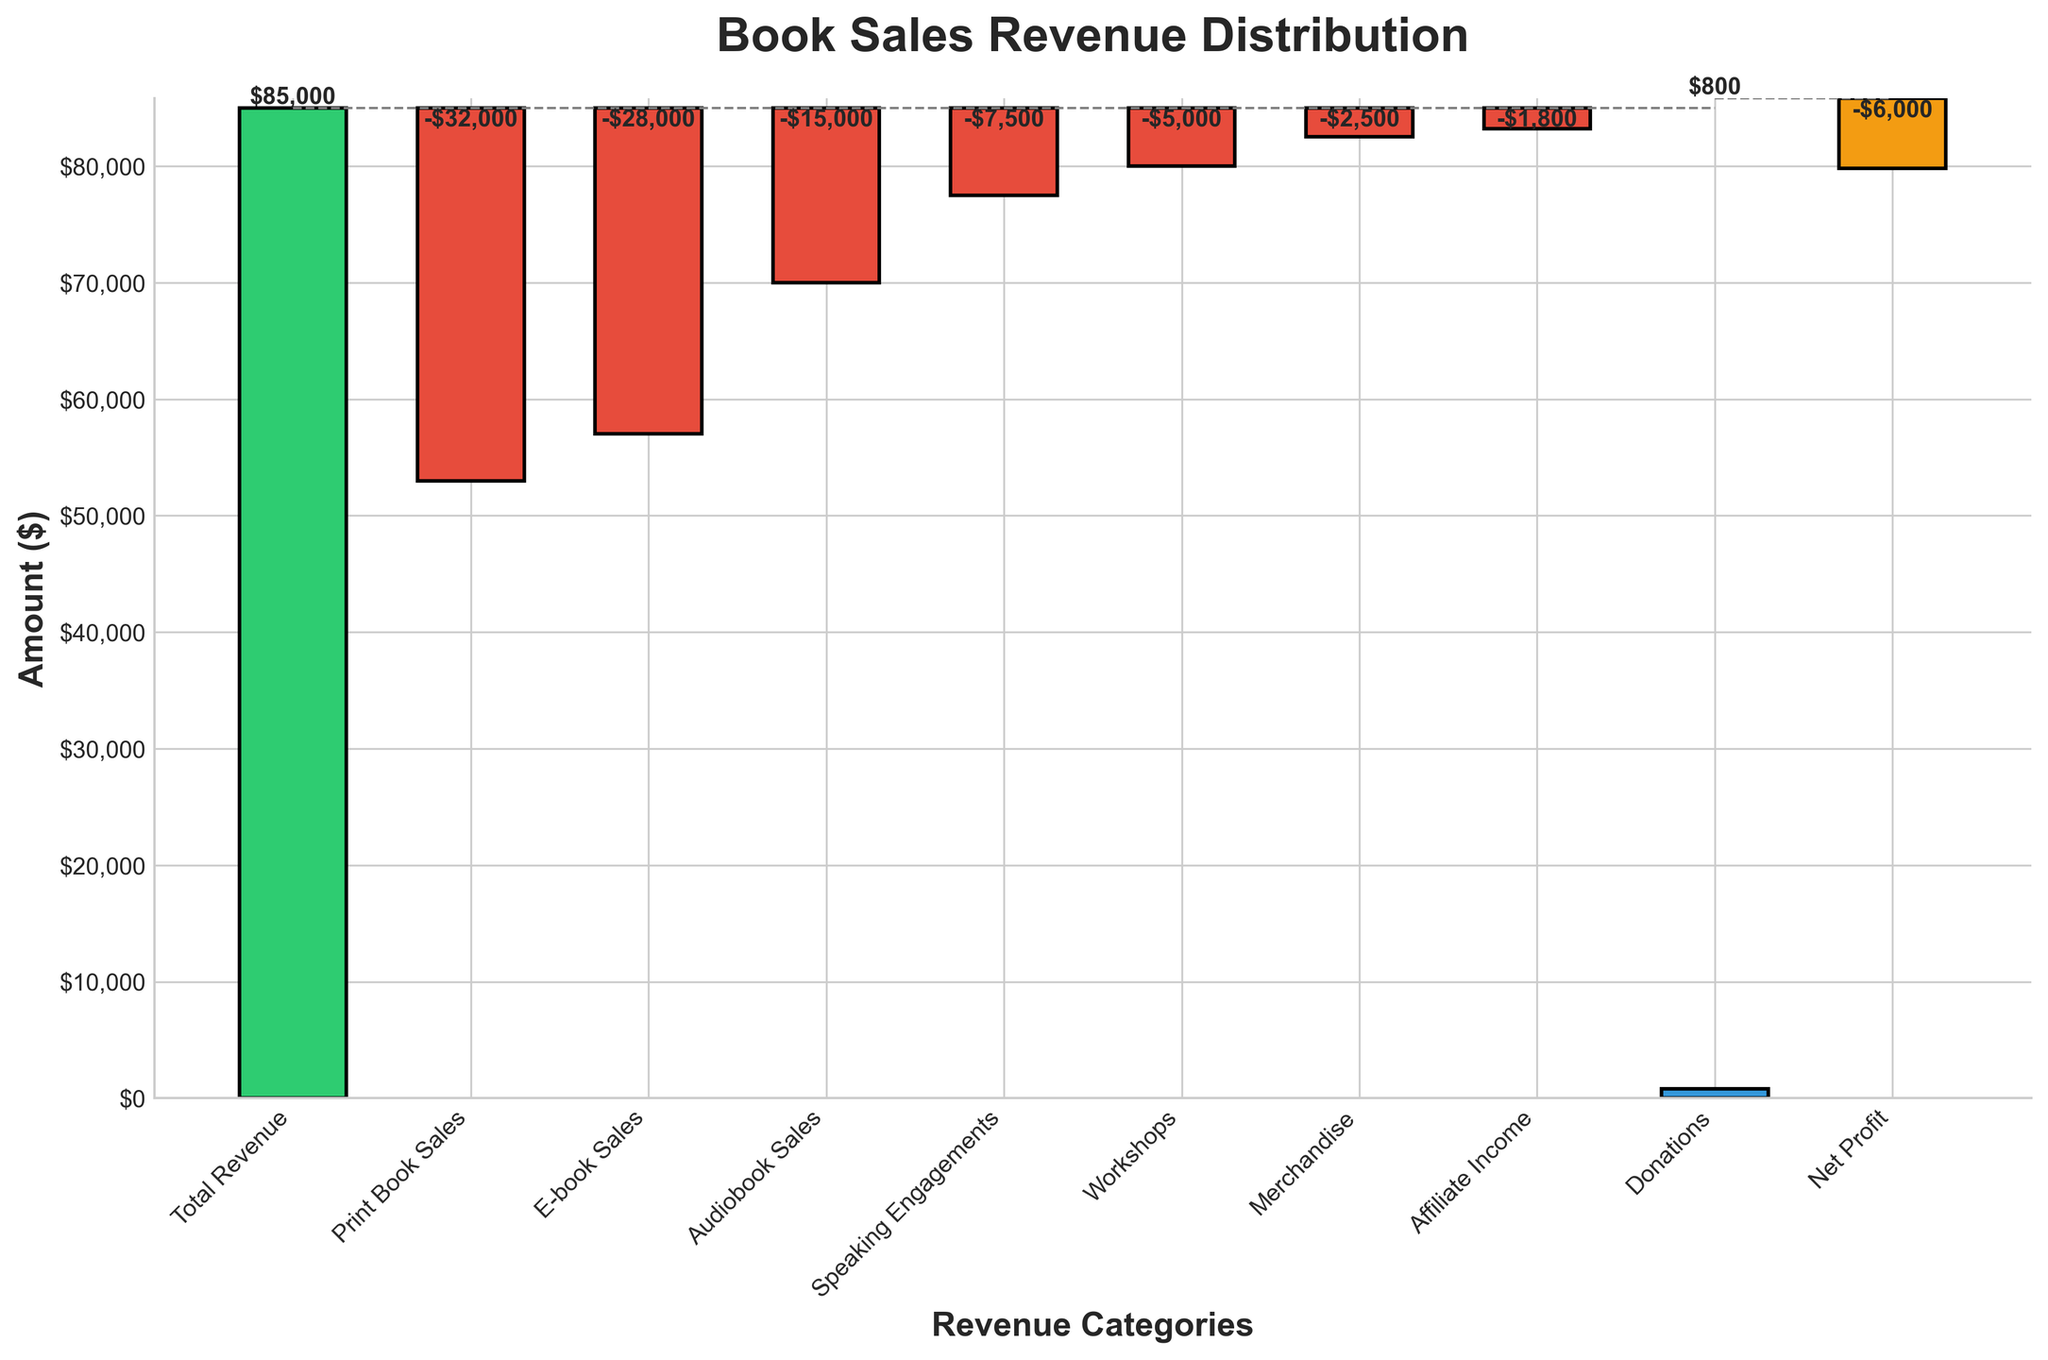What's the total revenue displayed in the chart? The title of the first bar in the waterfall chart is "Total Revenue," which indicates the overall revenue amount. The value displayed on this bar is $85,000.
Answer: $85,000 How much was generated from speaking engagements? The bar labeled "Speaking Engagements" shows the revenue or cost associated with that category. This bar has a value of -$7,500 indicated by its position below the zero line.
Answer: -$7,500 What is the highest revenue category other than Total Revenue? By inspecting the chart, the bar labeled "Donations" is the only bar in the positive range excluding "Total Revenue" and has a value of $800, which is the highest among the categories labeled separately from "Total Revenue."
Answer: $800 Which two categories have the closest value? Comparing the heights of all bars, "Affiliate Income" and "Donations" have values of -$1,800 and $800 respectively. While they differ in sign, their absolute values are close, with a difference of 2600.
Answer: Affiliate Income and Donations What would be the net profit without incorporating donations? Net profit including donations is -$6,000, and the donation amount is $800. To find the net profit excluding donations, subtract $800 from the net profit, resulting in -$6,800.
Answer: -$6,800 Which category causes the largest decrease in the overall revenue? Among the bars labeled with negative values (in the red color), "Print Book Sales" has the greatest negative value, specifically a value of -$32,000, which is the largest decrease.
Answer: Print Book Sales Which revenue category is positioned between Audiobook Sales and Workshops? Inspecting the sequence of bars reveals that "Speaking Engagements" falls between the categories "Audiobook Sales" and "Workshops."
Answer: Speaking Engagements How does the sum of "Print Book Sales" and "E-book Sales" compare to the Total Revenue? Adding the values from "Print Book Sales" (-$32,000) and "E-book Sales" (-$28,000) results in -$60,000. Comparing this with the "Total Revenue" of $85,000 shows a significant reduction.
Answer: -$60,000 compared to $85,000 What's the cumulative loss starting from "Print Book Sales" to "Affiliate Income"? Starting from "Print Book Sales" (-$32,000), add the values of the subsequent negative bars: -$32,000 + (-$28,000) + (-$15,000) + (-$7,500) + (-$5,000) + (-$2,500) + (-$1,800) = -$91,800.
Answer: -$91,800 